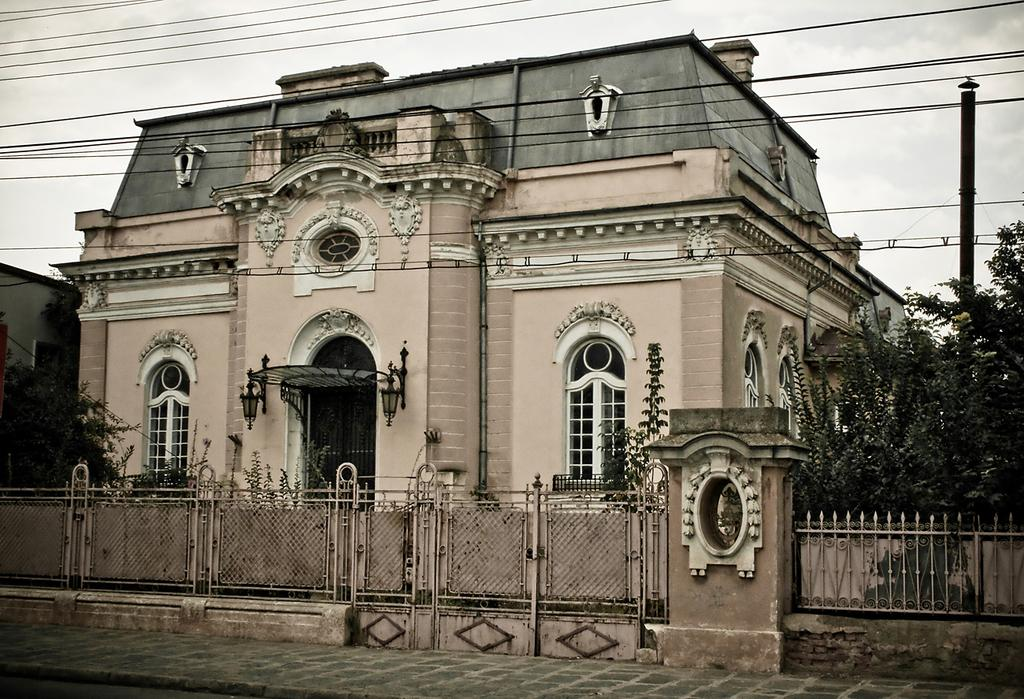What type of structure is present in the image? There is a building in the image. What is located near the building? There is a fence in the image. What other objects can be seen in the image? There is a pole, trees, and wires in the image. What can be seen in the background of the image? The sky is visible in the background of the image. What type of paper is the judge holding in the image? There is no judge or paper present in the image. What type of bushes can be seen near the trees in the image? There is no mention of bushes in the provided facts, and therefore we cannot determine if they are present in the image. 